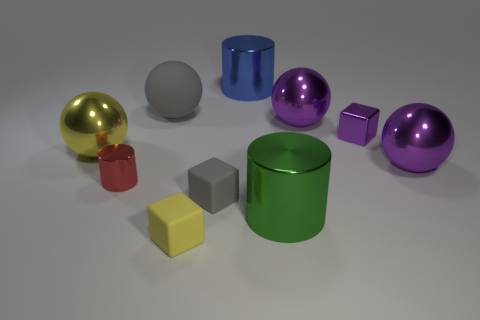Subtract all brown spheres. Subtract all blue cylinders. How many spheres are left? 4 Subtract all cylinders. How many objects are left? 7 Add 2 red objects. How many red objects are left? 3 Add 8 big gray spheres. How many big gray spheres exist? 9 Subtract 0 cyan cylinders. How many objects are left? 10 Subtract all green metallic objects. Subtract all small objects. How many objects are left? 5 